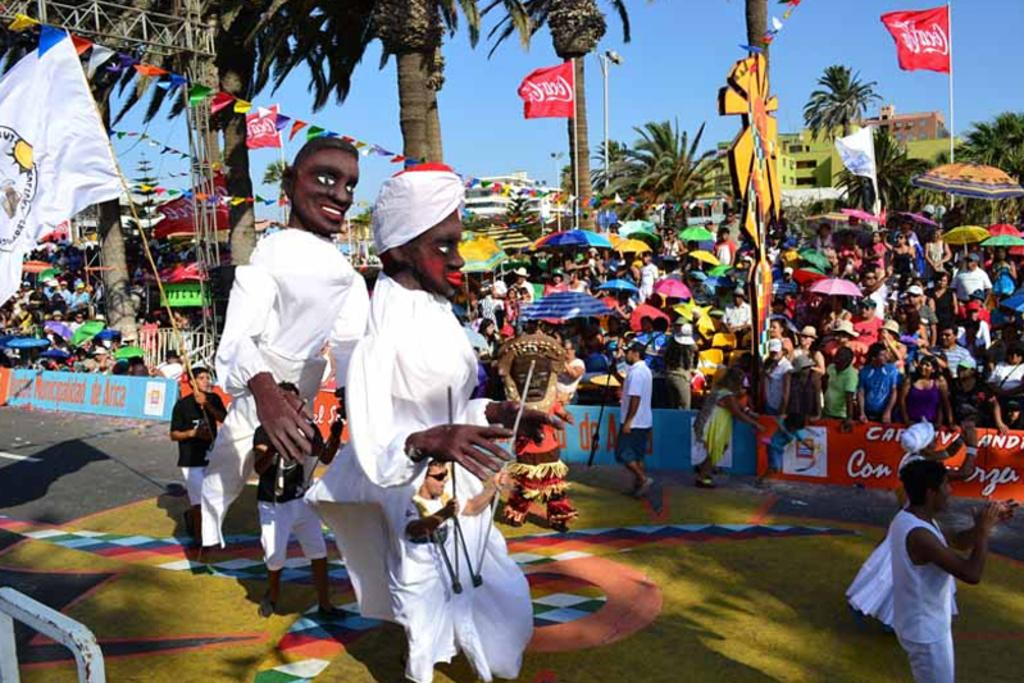<image>
Share a concise interpretation of the image provided. People march in a parade under red Coca-Cola flags 